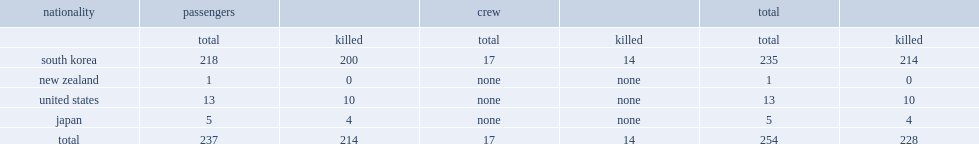How many passengers did the korean air flight 801 carry? 237.0. 